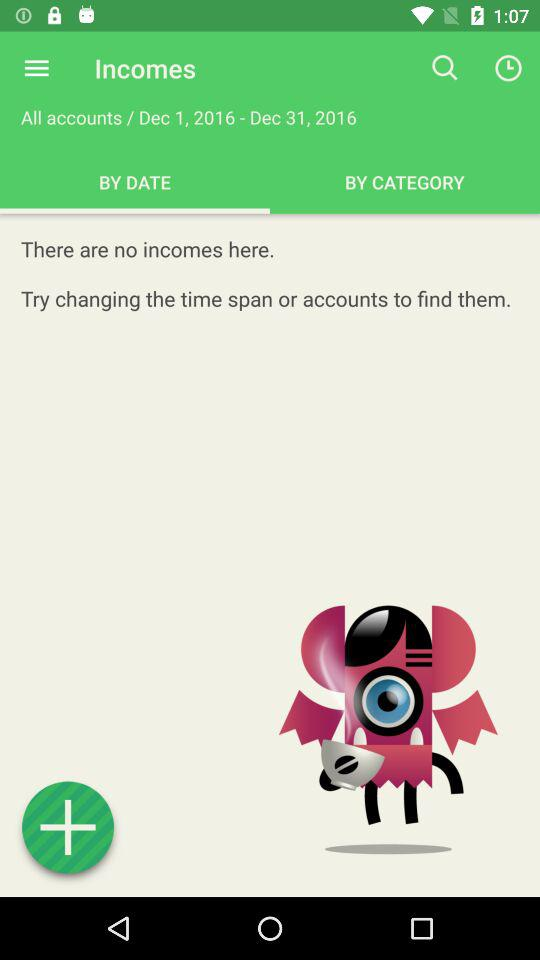What is the shown date range? The shown date range is from December 1, 2016 to December 31, 2016. 